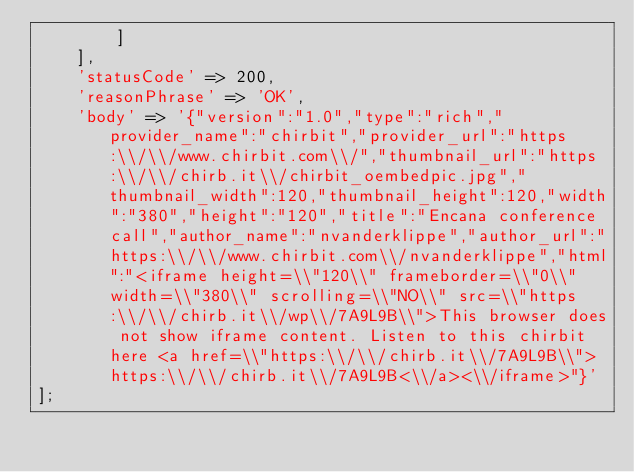Convert code to text. <code><loc_0><loc_0><loc_500><loc_500><_PHP_>        ]
    ],
    'statusCode' => 200,
    'reasonPhrase' => 'OK',
    'body' => '{"version":"1.0","type":"rich","provider_name":"chirbit","provider_url":"https:\\/\\/www.chirbit.com\\/","thumbnail_url":"https:\\/\\/chirb.it\\/chirbit_oembedpic.jpg","thumbnail_width":120,"thumbnail_height":120,"width":"380","height":"120","title":"Encana conference call","author_name":"nvanderklippe","author_url":"https:\\/\\/www.chirbit.com\\/nvanderklippe","html":"<iframe height=\\"120\\" frameborder=\\"0\\" width=\\"380\\" scrolling=\\"NO\\" src=\\"https:\\/\\/chirb.it\\/wp\\/7A9L9B\\">This browser does not show iframe content. Listen to this chirbit here <a href=\\"https:\\/\\/chirb.it\\/7A9L9B\\">https:\\/\\/chirb.it\\/7A9L9B<\\/a><\\/iframe>"}'
];
</code> 